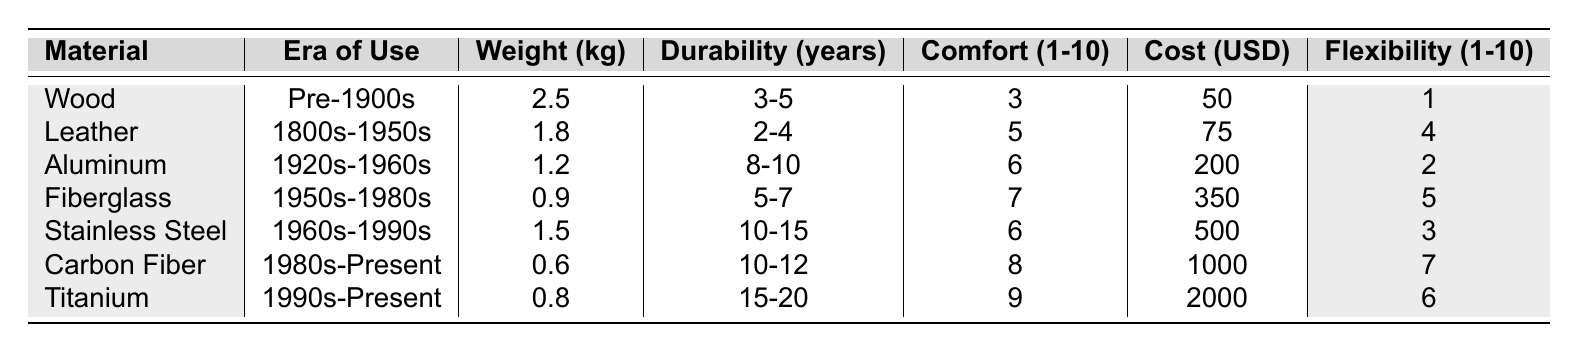What is the weight of the heaviest material? The heaviest material listed in the table is wood, with a weight of 2.5 kg. I looked at the "Weight (kg)" column and identified the highest value.
Answer: 2.5 kg Which material has the highest durability? The material with the highest durability is titanium, with a durability of 15-20 years. I compared the ranges in the "Durability (years)" column and found titanium has the greatest range.
Answer: 15-20 years How much does carbon fiber cost? The cost of carbon fiber listed in the table is 1000 USD. I found this by looking in the "Cost (USD)" column for carbon fiber.
Answer: 1000 USD Which era did leather prosthetic limbs belong to? Leather prosthetic limbs were used from the 1800s to the 1950s, as stated in the "Era of Use" column.
Answer: 1800s-1950s What is the average comfort rating of materials from the 1800s or earlier? The comfort ratings for materials from the 1800s or earlier are wood (3) and leather (5). The average is calculated as (3 + 5) / 2 = 4.
Answer: 4 Which material has a cost less than 100 USD? The only material with a cost less than 100 USD is wood, which costs 50 USD. I checked the "Cost (USD)" column for values below 100.
Answer: Yes What material offers the best flexibility rating? The material that offers the best flexibility rating is carbon fiber with a score of 7. I looked at the "Flexibility (1-10)" column for the highest score.
Answer: 7 Is aluminum more comfortable than leather? Aluminum has a comfort rating of 6, while leather has a rating of 5. Therefore, aluminum is more comfortable than leather. I compared the two values in the "Comfort (1-10)" column.
Answer: Yes How do the weights of fiberglass and titanium compare? Fiberglass weighs 0.9 kg and titanium weighs 0.8 kg, so fiberglass is heavier. I directly compared the "Weight (kg)" values for both materials.
Answer: Fiberglass is heavier What is the total cost of the materials from the 1900s and earlier? The costs for wood (50), leather (75), and aluminum (200) add up to 325. I summed the values from the "Cost (USD)" column for those materials.
Answer: 325 USD What is the median comfort rating across all materials? The comfort ratings are 3, 5, 6, 7, 6, 8, and 9. Arranging these in order gives 3, 5, 6, 6, 7, 8, 9. The median is the middle value, which is 6.
Answer: 6 Which material provides a balance of low weight and high durability? Carbon fiber has a low weight (0.6 kg) and high durability (10-12 years). I evaluated the "Weight (kg)" and "Durability (years)" columns and found that carbon fiber fits both criteria well.
Answer: Carbon fiber 